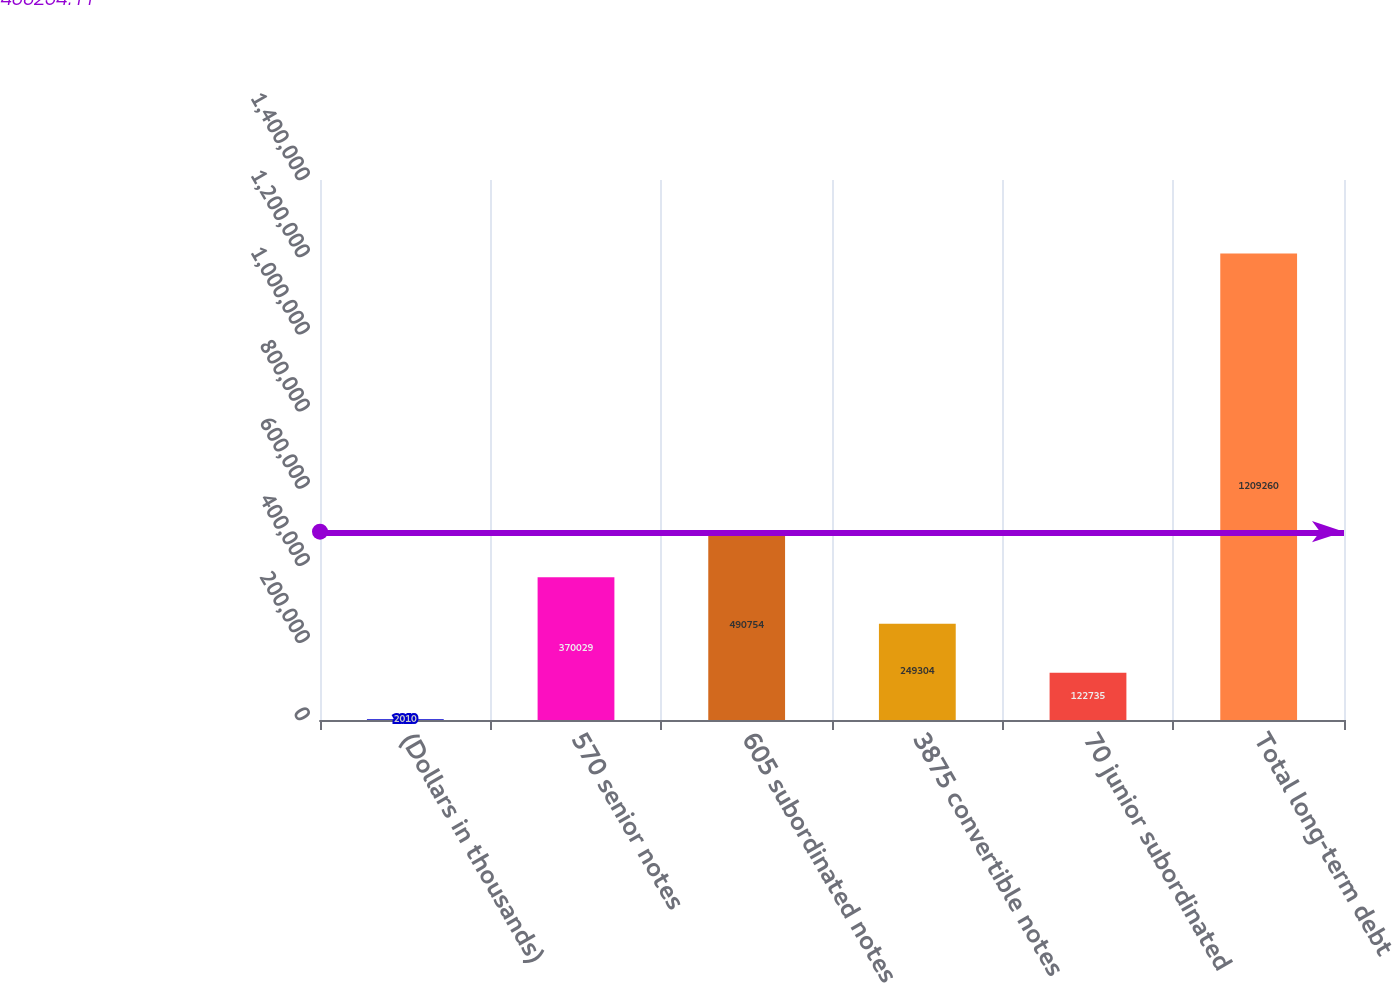Convert chart to OTSL. <chart><loc_0><loc_0><loc_500><loc_500><bar_chart><fcel>(Dollars in thousands)<fcel>570 senior notes<fcel>605 subordinated notes<fcel>3875 convertible notes<fcel>70 junior subordinated<fcel>Total long-term debt<nl><fcel>2010<fcel>370029<fcel>490754<fcel>249304<fcel>122735<fcel>1.20926e+06<nl></chart> 